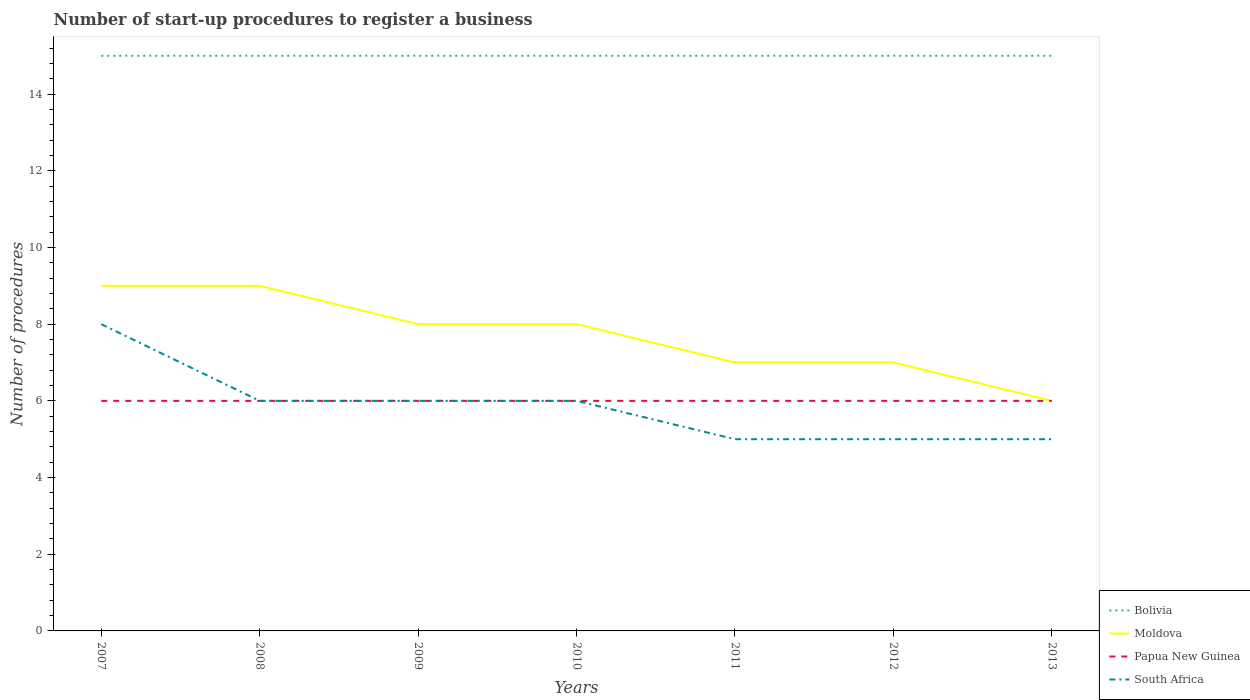Is the number of lines equal to the number of legend labels?
Make the answer very short. Yes. Across all years, what is the maximum number of procedures required to register a business in Bolivia?
Your answer should be very brief. 15. What is the difference between the highest and the second highest number of procedures required to register a business in South Africa?
Your answer should be very brief. 3. How many lines are there?
Provide a succinct answer. 4. Are the values on the major ticks of Y-axis written in scientific E-notation?
Give a very brief answer. No. Does the graph contain any zero values?
Offer a very short reply. No. Does the graph contain grids?
Make the answer very short. No. Where does the legend appear in the graph?
Offer a terse response. Bottom right. What is the title of the graph?
Provide a succinct answer. Number of start-up procedures to register a business. What is the label or title of the X-axis?
Offer a terse response. Years. What is the label or title of the Y-axis?
Your answer should be compact. Number of procedures. What is the Number of procedures of Bolivia in 2007?
Your answer should be very brief. 15. What is the Number of procedures in Papua New Guinea in 2007?
Provide a succinct answer. 6. What is the Number of procedures of Bolivia in 2008?
Offer a terse response. 15. What is the Number of procedures of Papua New Guinea in 2008?
Your answer should be very brief. 6. What is the Number of procedures in Bolivia in 2009?
Provide a short and direct response. 15. What is the Number of procedures in Papua New Guinea in 2010?
Provide a short and direct response. 6. What is the Number of procedures of Moldova in 2011?
Ensure brevity in your answer.  7. What is the Number of procedures in South Africa in 2011?
Ensure brevity in your answer.  5. What is the Number of procedures of Bolivia in 2012?
Provide a short and direct response. 15. What is the Number of procedures in Papua New Guinea in 2012?
Your answer should be compact. 6. What is the Number of procedures of Moldova in 2013?
Provide a short and direct response. 6. What is the Number of procedures of South Africa in 2013?
Offer a terse response. 5. Across all years, what is the maximum Number of procedures in Bolivia?
Offer a terse response. 15. Across all years, what is the maximum Number of procedures in South Africa?
Give a very brief answer. 8. Across all years, what is the minimum Number of procedures in Moldova?
Ensure brevity in your answer.  6. What is the total Number of procedures in Bolivia in the graph?
Offer a terse response. 105. What is the total Number of procedures of Moldova in the graph?
Make the answer very short. 54. What is the total Number of procedures of South Africa in the graph?
Your answer should be very brief. 41. What is the difference between the Number of procedures in Moldova in 2007 and that in 2009?
Ensure brevity in your answer.  1. What is the difference between the Number of procedures in Bolivia in 2007 and that in 2010?
Your answer should be compact. 0. What is the difference between the Number of procedures in Moldova in 2007 and that in 2010?
Offer a terse response. 1. What is the difference between the Number of procedures of Papua New Guinea in 2007 and that in 2010?
Your answer should be compact. 0. What is the difference between the Number of procedures in Bolivia in 2007 and that in 2011?
Your response must be concise. 0. What is the difference between the Number of procedures of Moldova in 2007 and that in 2011?
Give a very brief answer. 2. What is the difference between the Number of procedures in Papua New Guinea in 2007 and that in 2011?
Offer a very short reply. 0. What is the difference between the Number of procedures of South Africa in 2007 and that in 2011?
Ensure brevity in your answer.  3. What is the difference between the Number of procedures of Bolivia in 2007 and that in 2012?
Ensure brevity in your answer.  0. What is the difference between the Number of procedures in Papua New Guinea in 2007 and that in 2012?
Offer a very short reply. 0. What is the difference between the Number of procedures of South Africa in 2007 and that in 2012?
Provide a succinct answer. 3. What is the difference between the Number of procedures of Bolivia in 2007 and that in 2013?
Make the answer very short. 0. What is the difference between the Number of procedures of Moldova in 2007 and that in 2013?
Give a very brief answer. 3. What is the difference between the Number of procedures in Papua New Guinea in 2007 and that in 2013?
Provide a short and direct response. 0. What is the difference between the Number of procedures of Bolivia in 2008 and that in 2009?
Offer a very short reply. 0. What is the difference between the Number of procedures in Papua New Guinea in 2008 and that in 2009?
Offer a very short reply. 0. What is the difference between the Number of procedures in South Africa in 2008 and that in 2009?
Give a very brief answer. 0. What is the difference between the Number of procedures in Papua New Guinea in 2008 and that in 2010?
Your response must be concise. 0. What is the difference between the Number of procedures of South Africa in 2008 and that in 2010?
Your answer should be compact. 0. What is the difference between the Number of procedures of Bolivia in 2008 and that in 2011?
Provide a succinct answer. 0. What is the difference between the Number of procedures of Papua New Guinea in 2008 and that in 2012?
Give a very brief answer. 0. What is the difference between the Number of procedures of South Africa in 2008 and that in 2012?
Offer a terse response. 1. What is the difference between the Number of procedures of Bolivia in 2008 and that in 2013?
Offer a terse response. 0. What is the difference between the Number of procedures in Moldova in 2008 and that in 2013?
Your response must be concise. 3. What is the difference between the Number of procedures in Papua New Guinea in 2008 and that in 2013?
Your response must be concise. 0. What is the difference between the Number of procedures in Moldova in 2009 and that in 2011?
Make the answer very short. 1. What is the difference between the Number of procedures of South Africa in 2009 and that in 2011?
Offer a very short reply. 1. What is the difference between the Number of procedures in Moldova in 2009 and that in 2012?
Keep it short and to the point. 1. What is the difference between the Number of procedures of Papua New Guinea in 2009 and that in 2012?
Your response must be concise. 0. What is the difference between the Number of procedures of South Africa in 2009 and that in 2012?
Provide a short and direct response. 1. What is the difference between the Number of procedures of Moldova in 2009 and that in 2013?
Keep it short and to the point. 2. What is the difference between the Number of procedures of South Africa in 2009 and that in 2013?
Your answer should be very brief. 1. What is the difference between the Number of procedures of Bolivia in 2010 and that in 2011?
Your answer should be compact. 0. What is the difference between the Number of procedures of Moldova in 2010 and that in 2011?
Offer a terse response. 1. What is the difference between the Number of procedures of Papua New Guinea in 2010 and that in 2012?
Keep it short and to the point. 0. What is the difference between the Number of procedures in South Africa in 2010 and that in 2012?
Make the answer very short. 1. What is the difference between the Number of procedures in Papua New Guinea in 2010 and that in 2013?
Provide a short and direct response. 0. What is the difference between the Number of procedures in South Africa in 2010 and that in 2013?
Your response must be concise. 1. What is the difference between the Number of procedures of Bolivia in 2011 and that in 2012?
Your response must be concise. 0. What is the difference between the Number of procedures in Bolivia in 2011 and that in 2013?
Offer a terse response. 0. What is the difference between the Number of procedures in Moldova in 2011 and that in 2013?
Give a very brief answer. 1. What is the difference between the Number of procedures in South Africa in 2011 and that in 2013?
Your response must be concise. 0. What is the difference between the Number of procedures of Bolivia in 2012 and that in 2013?
Give a very brief answer. 0. What is the difference between the Number of procedures of Moldova in 2012 and that in 2013?
Ensure brevity in your answer.  1. What is the difference between the Number of procedures of Papua New Guinea in 2012 and that in 2013?
Keep it short and to the point. 0. What is the difference between the Number of procedures of Bolivia in 2007 and the Number of procedures of Moldova in 2008?
Your response must be concise. 6. What is the difference between the Number of procedures in Bolivia in 2007 and the Number of procedures in Papua New Guinea in 2008?
Your answer should be very brief. 9. What is the difference between the Number of procedures of Papua New Guinea in 2007 and the Number of procedures of South Africa in 2008?
Give a very brief answer. 0. What is the difference between the Number of procedures of Bolivia in 2007 and the Number of procedures of South Africa in 2009?
Make the answer very short. 9. What is the difference between the Number of procedures of Bolivia in 2007 and the Number of procedures of Moldova in 2010?
Provide a short and direct response. 7. What is the difference between the Number of procedures in Moldova in 2007 and the Number of procedures in Papua New Guinea in 2010?
Your answer should be very brief. 3. What is the difference between the Number of procedures of Moldova in 2007 and the Number of procedures of South Africa in 2010?
Make the answer very short. 3. What is the difference between the Number of procedures in Bolivia in 2007 and the Number of procedures in Moldova in 2011?
Offer a very short reply. 8. What is the difference between the Number of procedures of Bolivia in 2007 and the Number of procedures of Papua New Guinea in 2011?
Ensure brevity in your answer.  9. What is the difference between the Number of procedures of Bolivia in 2007 and the Number of procedures of South Africa in 2011?
Offer a terse response. 10. What is the difference between the Number of procedures of Moldova in 2007 and the Number of procedures of Papua New Guinea in 2012?
Your answer should be compact. 3. What is the difference between the Number of procedures of Papua New Guinea in 2007 and the Number of procedures of South Africa in 2012?
Ensure brevity in your answer.  1. What is the difference between the Number of procedures of Bolivia in 2007 and the Number of procedures of Moldova in 2013?
Your answer should be compact. 9. What is the difference between the Number of procedures of Bolivia in 2007 and the Number of procedures of Papua New Guinea in 2013?
Your response must be concise. 9. What is the difference between the Number of procedures of Bolivia in 2007 and the Number of procedures of South Africa in 2013?
Your answer should be very brief. 10. What is the difference between the Number of procedures in Moldova in 2007 and the Number of procedures in Papua New Guinea in 2013?
Your answer should be very brief. 3. What is the difference between the Number of procedures of Moldova in 2007 and the Number of procedures of South Africa in 2013?
Your answer should be very brief. 4. What is the difference between the Number of procedures of Papua New Guinea in 2007 and the Number of procedures of South Africa in 2013?
Provide a short and direct response. 1. What is the difference between the Number of procedures of Bolivia in 2008 and the Number of procedures of Moldova in 2009?
Make the answer very short. 7. What is the difference between the Number of procedures in Bolivia in 2008 and the Number of procedures in Papua New Guinea in 2009?
Give a very brief answer. 9. What is the difference between the Number of procedures of Bolivia in 2008 and the Number of procedures of South Africa in 2009?
Make the answer very short. 9. What is the difference between the Number of procedures of Moldova in 2008 and the Number of procedures of South Africa in 2009?
Your answer should be compact. 3. What is the difference between the Number of procedures in Papua New Guinea in 2008 and the Number of procedures in South Africa in 2009?
Offer a very short reply. 0. What is the difference between the Number of procedures of Bolivia in 2008 and the Number of procedures of South Africa in 2010?
Keep it short and to the point. 9. What is the difference between the Number of procedures of Papua New Guinea in 2008 and the Number of procedures of South Africa in 2011?
Offer a very short reply. 1. What is the difference between the Number of procedures in Bolivia in 2008 and the Number of procedures in Moldova in 2012?
Keep it short and to the point. 8. What is the difference between the Number of procedures in Bolivia in 2008 and the Number of procedures in Papua New Guinea in 2012?
Provide a short and direct response. 9. What is the difference between the Number of procedures in Papua New Guinea in 2008 and the Number of procedures in South Africa in 2012?
Offer a very short reply. 1. What is the difference between the Number of procedures of Bolivia in 2008 and the Number of procedures of South Africa in 2013?
Provide a succinct answer. 10. What is the difference between the Number of procedures of Moldova in 2008 and the Number of procedures of Papua New Guinea in 2013?
Make the answer very short. 3. What is the difference between the Number of procedures in Moldova in 2008 and the Number of procedures in South Africa in 2013?
Keep it short and to the point. 4. What is the difference between the Number of procedures of Papua New Guinea in 2008 and the Number of procedures of South Africa in 2013?
Provide a short and direct response. 1. What is the difference between the Number of procedures of Bolivia in 2009 and the Number of procedures of Moldova in 2010?
Your answer should be compact. 7. What is the difference between the Number of procedures of Bolivia in 2009 and the Number of procedures of South Africa in 2010?
Offer a very short reply. 9. What is the difference between the Number of procedures of Moldova in 2009 and the Number of procedures of South Africa in 2010?
Make the answer very short. 2. What is the difference between the Number of procedures of Papua New Guinea in 2009 and the Number of procedures of South Africa in 2010?
Keep it short and to the point. 0. What is the difference between the Number of procedures in Bolivia in 2009 and the Number of procedures in Papua New Guinea in 2011?
Your response must be concise. 9. What is the difference between the Number of procedures in Bolivia in 2009 and the Number of procedures in South Africa in 2011?
Give a very brief answer. 10. What is the difference between the Number of procedures in Bolivia in 2009 and the Number of procedures in Papua New Guinea in 2012?
Offer a very short reply. 9. What is the difference between the Number of procedures in Bolivia in 2009 and the Number of procedures in South Africa in 2012?
Your response must be concise. 10. What is the difference between the Number of procedures of Papua New Guinea in 2009 and the Number of procedures of South Africa in 2012?
Provide a short and direct response. 1. What is the difference between the Number of procedures in Bolivia in 2009 and the Number of procedures in South Africa in 2013?
Your response must be concise. 10. What is the difference between the Number of procedures of Moldova in 2009 and the Number of procedures of Papua New Guinea in 2013?
Offer a very short reply. 2. What is the difference between the Number of procedures of Moldova in 2009 and the Number of procedures of South Africa in 2013?
Offer a terse response. 3. What is the difference between the Number of procedures of Papua New Guinea in 2009 and the Number of procedures of South Africa in 2013?
Provide a succinct answer. 1. What is the difference between the Number of procedures of Bolivia in 2010 and the Number of procedures of Papua New Guinea in 2011?
Provide a succinct answer. 9. What is the difference between the Number of procedures of Moldova in 2010 and the Number of procedures of Papua New Guinea in 2011?
Offer a terse response. 2. What is the difference between the Number of procedures of Moldova in 2010 and the Number of procedures of South Africa in 2011?
Make the answer very short. 3. What is the difference between the Number of procedures in Bolivia in 2010 and the Number of procedures in Moldova in 2012?
Offer a very short reply. 8. What is the difference between the Number of procedures in Moldova in 2010 and the Number of procedures in Papua New Guinea in 2012?
Make the answer very short. 2. What is the difference between the Number of procedures of Bolivia in 2010 and the Number of procedures of Moldova in 2013?
Your answer should be very brief. 9. What is the difference between the Number of procedures of Bolivia in 2010 and the Number of procedures of South Africa in 2013?
Offer a very short reply. 10. What is the difference between the Number of procedures in Papua New Guinea in 2010 and the Number of procedures in South Africa in 2013?
Keep it short and to the point. 1. What is the difference between the Number of procedures in Moldova in 2011 and the Number of procedures in Papua New Guinea in 2012?
Provide a short and direct response. 1. What is the difference between the Number of procedures of Moldova in 2011 and the Number of procedures of South Africa in 2012?
Offer a very short reply. 2. What is the difference between the Number of procedures in Bolivia in 2011 and the Number of procedures in Papua New Guinea in 2013?
Offer a terse response. 9. What is the difference between the Number of procedures in Bolivia in 2011 and the Number of procedures in South Africa in 2013?
Offer a terse response. 10. What is the difference between the Number of procedures of Papua New Guinea in 2011 and the Number of procedures of South Africa in 2013?
Offer a very short reply. 1. What is the difference between the Number of procedures in Bolivia in 2012 and the Number of procedures in Moldova in 2013?
Ensure brevity in your answer.  9. What is the difference between the Number of procedures in Bolivia in 2012 and the Number of procedures in Papua New Guinea in 2013?
Your answer should be compact. 9. What is the difference between the Number of procedures of Bolivia in 2012 and the Number of procedures of South Africa in 2013?
Your response must be concise. 10. What is the difference between the Number of procedures in Moldova in 2012 and the Number of procedures in Papua New Guinea in 2013?
Your answer should be compact. 1. What is the average Number of procedures in Moldova per year?
Your answer should be very brief. 7.71. What is the average Number of procedures in South Africa per year?
Ensure brevity in your answer.  5.86. In the year 2007, what is the difference between the Number of procedures of Bolivia and Number of procedures of Moldova?
Your response must be concise. 6. In the year 2007, what is the difference between the Number of procedures in Bolivia and Number of procedures in South Africa?
Provide a short and direct response. 7. In the year 2007, what is the difference between the Number of procedures in Moldova and Number of procedures in Papua New Guinea?
Your answer should be very brief. 3. In the year 2007, what is the difference between the Number of procedures of Moldova and Number of procedures of South Africa?
Give a very brief answer. 1. In the year 2008, what is the difference between the Number of procedures of Papua New Guinea and Number of procedures of South Africa?
Ensure brevity in your answer.  0. In the year 2009, what is the difference between the Number of procedures of Bolivia and Number of procedures of Moldova?
Your answer should be compact. 7. In the year 2009, what is the difference between the Number of procedures in Bolivia and Number of procedures in South Africa?
Give a very brief answer. 9. In the year 2009, what is the difference between the Number of procedures of Moldova and Number of procedures of Papua New Guinea?
Your answer should be very brief. 2. In the year 2009, what is the difference between the Number of procedures of Moldova and Number of procedures of South Africa?
Provide a succinct answer. 2. In the year 2010, what is the difference between the Number of procedures of Moldova and Number of procedures of Papua New Guinea?
Provide a short and direct response. 2. In the year 2010, what is the difference between the Number of procedures of Moldova and Number of procedures of South Africa?
Your answer should be compact. 2. In the year 2010, what is the difference between the Number of procedures of Papua New Guinea and Number of procedures of South Africa?
Your answer should be compact. 0. In the year 2011, what is the difference between the Number of procedures in Bolivia and Number of procedures in Papua New Guinea?
Your answer should be compact. 9. In the year 2011, what is the difference between the Number of procedures in Bolivia and Number of procedures in South Africa?
Your answer should be very brief. 10. In the year 2011, what is the difference between the Number of procedures of Moldova and Number of procedures of South Africa?
Provide a short and direct response. 2. In the year 2011, what is the difference between the Number of procedures of Papua New Guinea and Number of procedures of South Africa?
Your answer should be very brief. 1. In the year 2012, what is the difference between the Number of procedures of Bolivia and Number of procedures of Moldova?
Ensure brevity in your answer.  8. In the year 2013, what is the difference between the Number of procedures in Moldova and Number of procedures in Papua New Guinea?
Your answer should be compact. 0. In the year 2013, what is the difference between the Number of procedures of Moldova and Number of procedures of South Africa?
Provide a short and direct response. 1. In the year 2013, what is the difference between the Number of procedures of Papua New Guinea and Number of procedures of South Africa?
Your answer should be compact. 1. What is the ratio of the Number of procedures in Moldova in 2007 to that in 2009?
Offer a terse response. 1.12. What is the ratio of the Number of procedures in Papua New Guinea in 2007 to that in 2009?
Provide a short and direct response. 1. What is the ratio of the Number of procedures in Moldova in 2007 to that in 2010?
Provide a succinct answer. 1.12. What is the ratio of the Number of procedures in Papua New Guinea in 2007 to that in 2010?
Make the answer very short. 1. What is the ratio of the Number of procedures of South Africa in 2007 to that in 2011?
Your response must be concise. 1.6. What is the ratio of the Number of procedures of Moldova in 2008 to that in 2009?
Your answer should be very brief. 1.12. What is the ratio of the Number of procedures of South Africa in 2008 to that in 2009?
Provide a short and direct response. 1. What is the ratio of the Number of procedures of Moldova in 2008 to that in 2011?
Provide a short and direct response. 1.29. What is the ratio of the Number of procedures in Papua New Guinea in 2008 to that in 2011?
Offer a very short reply. 1. What is the ratio of the Number of procedures in Moldova in 2008 to that in 2012?
Your response must be concise. 1.29. What is the ratio of the Number of procedures of Papua New Guinea in 2008 to that in 2012?
Your answer should be compact. 1. What is the ratio of the Number of procedures of Bolivia in 2008 to that in 2013?
Your answer should be very brief. 1. What is the ratio of the Number of procedures in South Africa in 2008 to that in 2013?
Make the answer very short. 1.2. What is the ratio of the Number of procedures in Bolivia in 2009 to that in 2010?
Keep it short and to the point. 1. What is the ratio of the Number of procedures in Papua New Guinea in 2009 to that in 2010?
Your answer should be very brief. 1. What is the ratio of the Number of procedures of Bolivia in 2009 to that in 2011?
Ensure brevity in your answer.  1. What is the ratio of the Number of procedures in Papua New Guinea in 2009 to that in 2011?
Provide a short and direct response. 1. What is the ratio of the Number of procedures of Bolivia in 2009 to that in 2012?
Give a very brief answer. 1. What is the ratio of the Number of procedures in Papua New Guinea in 2009 to that in 2012?
Your response must be concise. 1. What is the ratio of the Number of procedures of Bolivia in 2009 to that in 2013?
Offer a very short reply. 1. What is the ratio of the Number of procedures of Bolivia in 2010 to that in 2011?
Provide a short and direct response. 1. What is the ratio of the Number of procedures of Papua New Guinea in 2010 to that in 2012?
Keep it short and to the point. 1. What is the ratio of the Number of procedures in Moldova in 2010 to that in 2013?
Ensure brevity in your answer.  1.33. What is the ratio of the Number of procedures in Papua New Guinea in 2010 to that in 2013?
Provide a succinct answer. 1. What is the ratio of the Number of procedures of South Africa in 2010 to that in 2013?
Your answer should be very brief. 1.2. What is the ratio of the Number of procedures in Moldova in 2011 to that in 2012?
Your answer should be compact. 1. What is the ratio of the Number of procedures in South Africa in 2011 to that in 2012?
Your answer should be compact. 1. What is the ratio of the Number of procedures in Bolivia in 2011 to that in 2013?
Keep it short and to the point. 1. What is the ratio of the Number of procedures in Moldova in 2011 to that in 2013?
Your answer should be very brief. 1.17. What is the ratio of the Number of procedures in South Africa in 2011 to that in 2013?
Offer a very short reply. 1. What is the ratio of the Number of procedures of Moldova in 2012 to that in 2013?
Your response must be concise. 1.17. What is the difference between the highest and the lowest Number of procedures of Bolivia?
Keep it short and to the point. 0. What is the difference between the highest and the lowest Number of procedures in South Africa?
Your response must be concise. 3. 